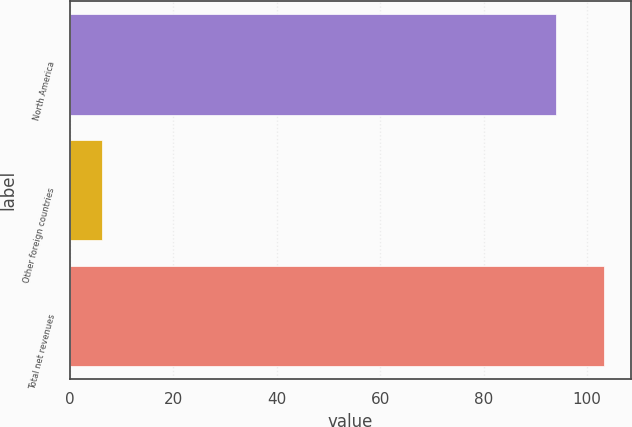Convert chart. <chart><loc_0><loc_0><loc_500><loc_500><bar_chart><fcel>North America<fcel>Other foreign countries<fcel>Total net revenues<nl><fcel>93.9<fcel>6.1<fcel>103.29<nl></chart> 